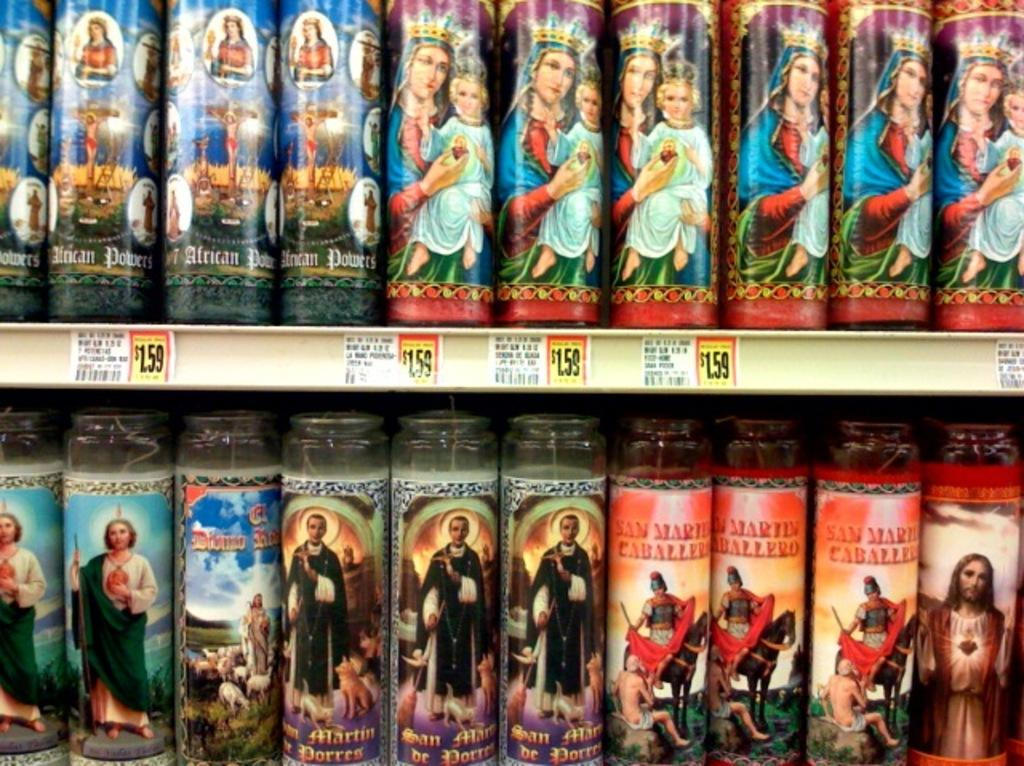How many shelves are present in the image? There are two shelves in the image. What can be found on the shelves? There are bottles on the shelves. Are there any indications of the cost of the items in the image? Yes, there are price tags visible in the image. What types of toys are displayed on the shelves in the image? There are no toys present in the image; it features shelves with bottles and price tags. What flavors of jelly can be seen on the shelves in the image? There is no jelly visible in the image; it only shows bottles and price tags on the shelves. 